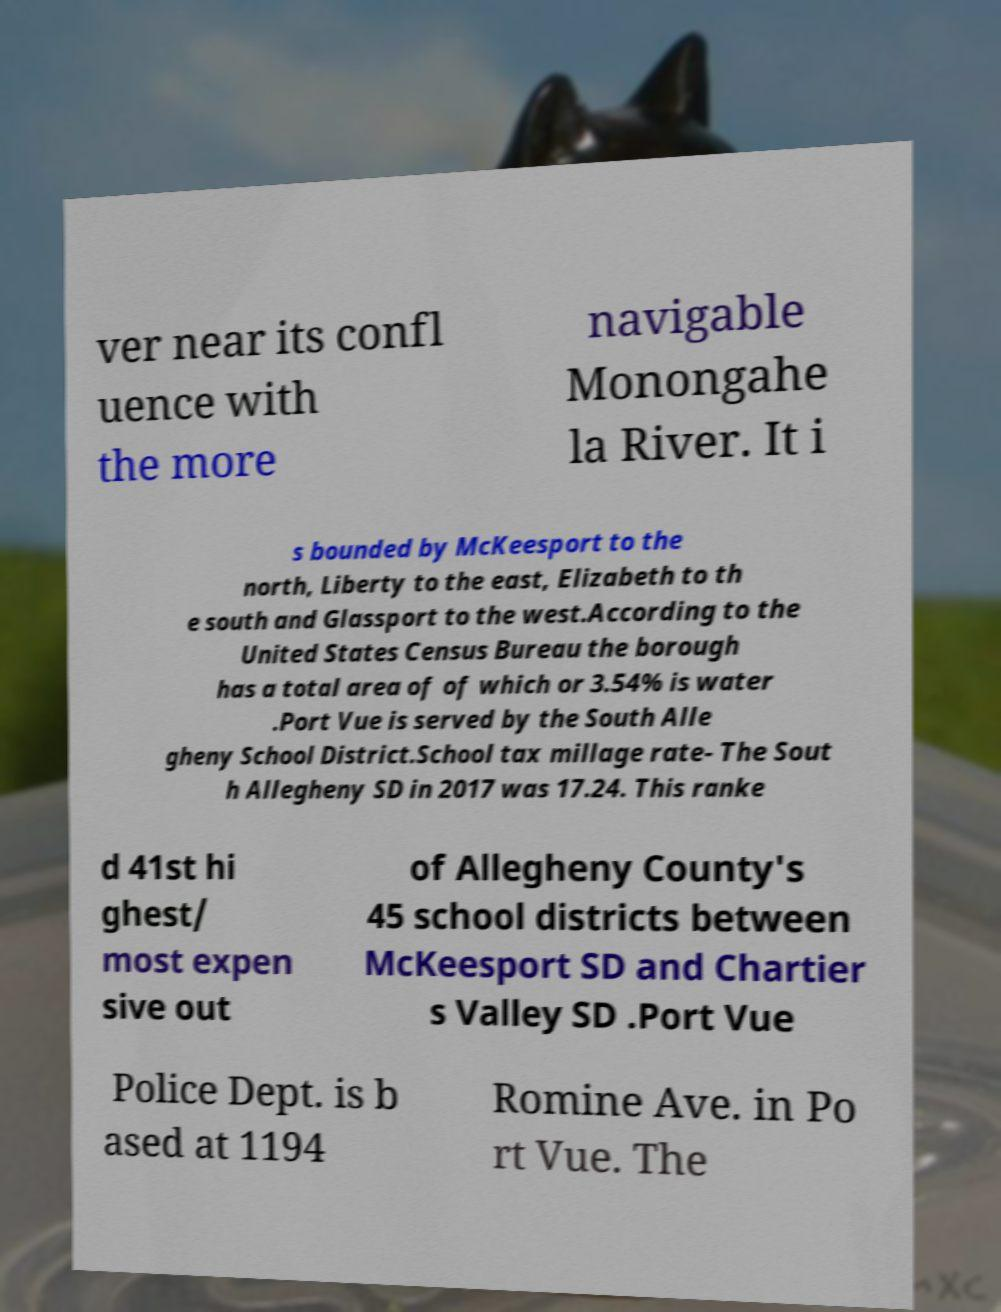Can you accurately transcribe the text from the provided image for me? ver near its confl uence with the more navigable Monongahe la River. It i s bounded by McKeesport to the north, Liberty to the east, Elizabeth to th e south and Glassport to the west.According to the United States Census Bureau the borough has a total area of of which or 3.54% is water .Port Vue is served by the South Alle gheny School District.School tax millage rate- The Sout h Allegheny SD in 2017 was 17.24. This ranke d 41st hi ghest/ most expen sive out of Allegheny County's 45 school districts between McKeesport SD and Chartier s Valley SD .Port Vue Police Dept. is b ased at 1194 Romine Ave. in Po rt Vue. The 